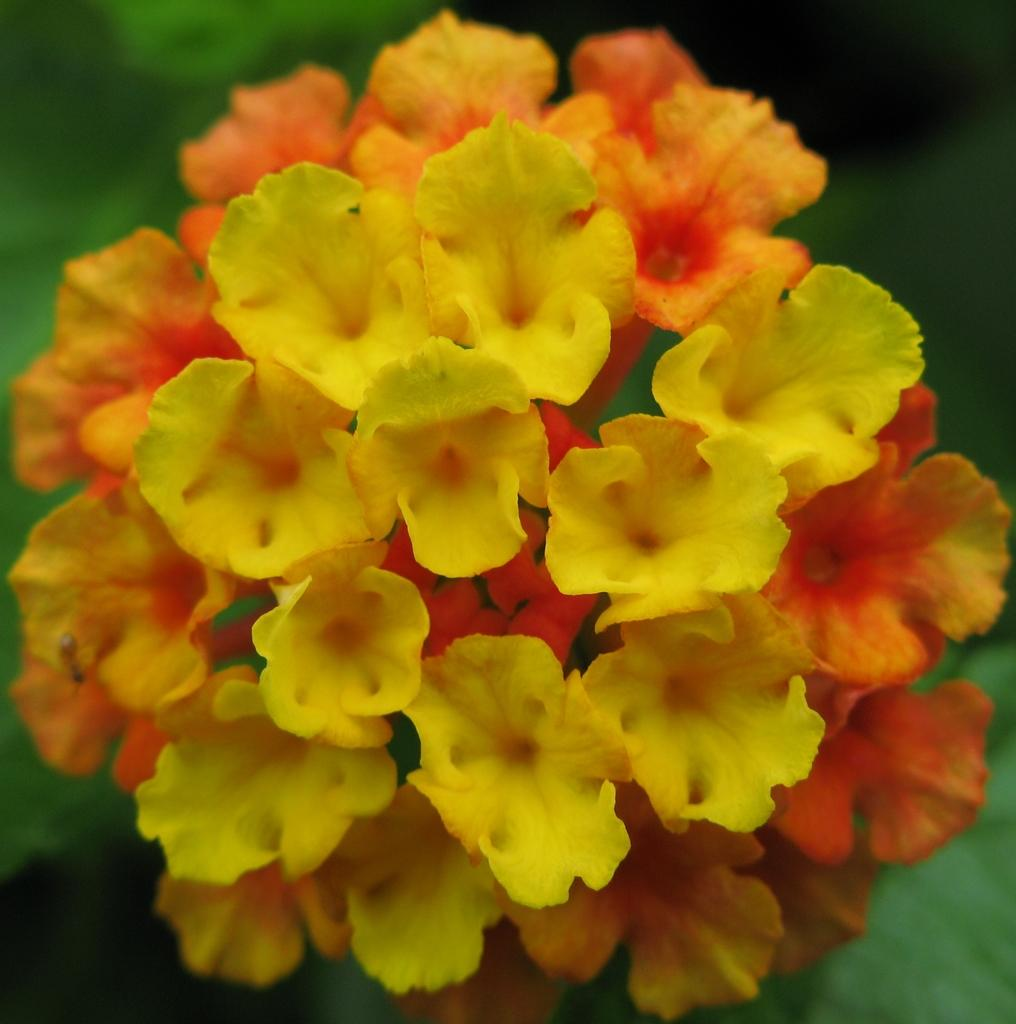What is present in the image? There are flowers in the image. How would you describe the background of the image? The background of the image is blurred and appears to be greenery. What type of bird can be seen wearing a boot in the image? There is no bird or boot present in the image; it only features flowers and a blurred background of greenery. 